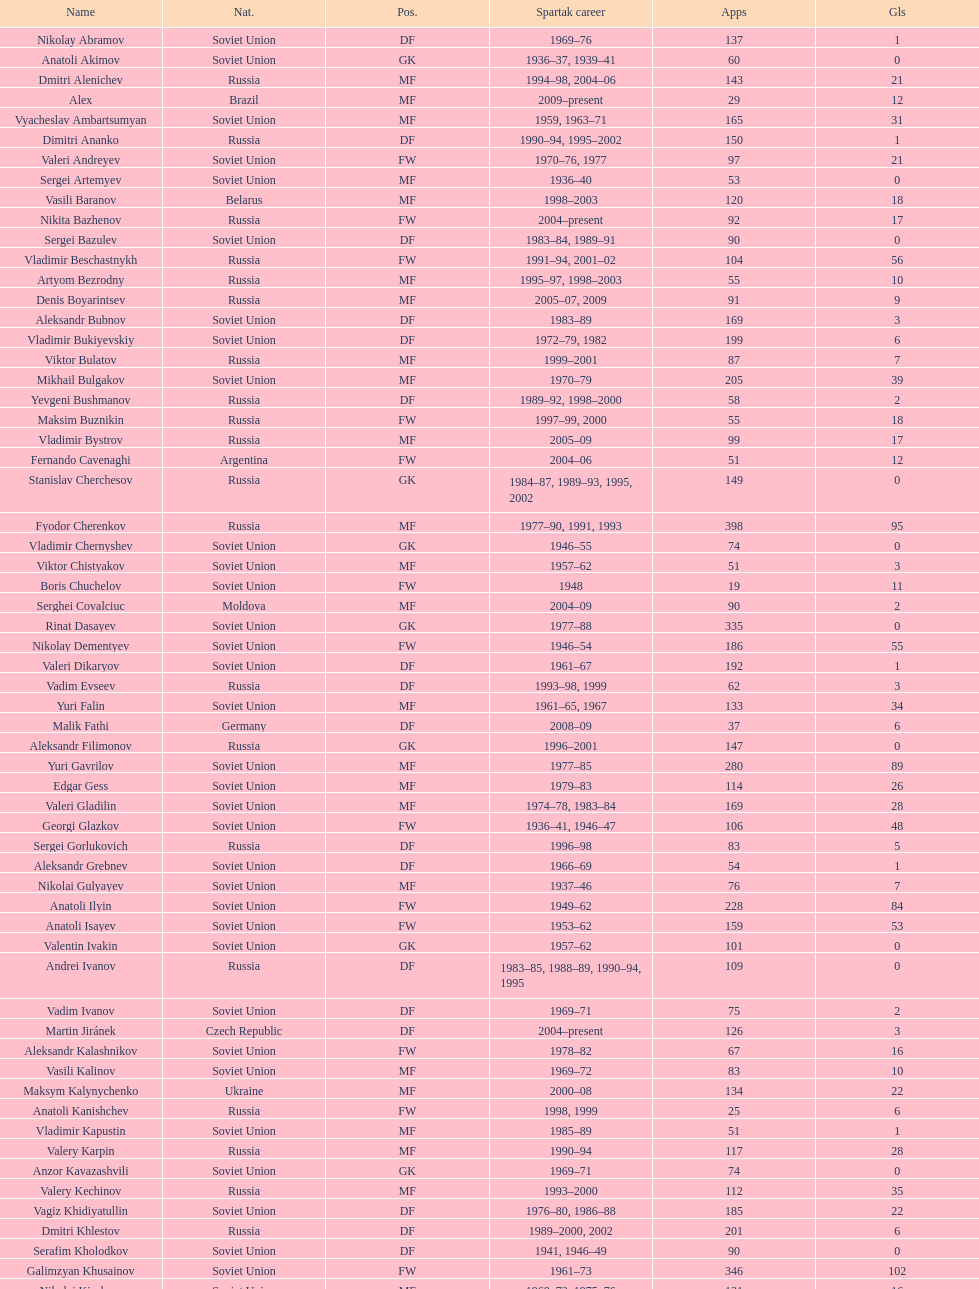Baranov has played from 2004 to the present. what is his nationality? Belarus. 